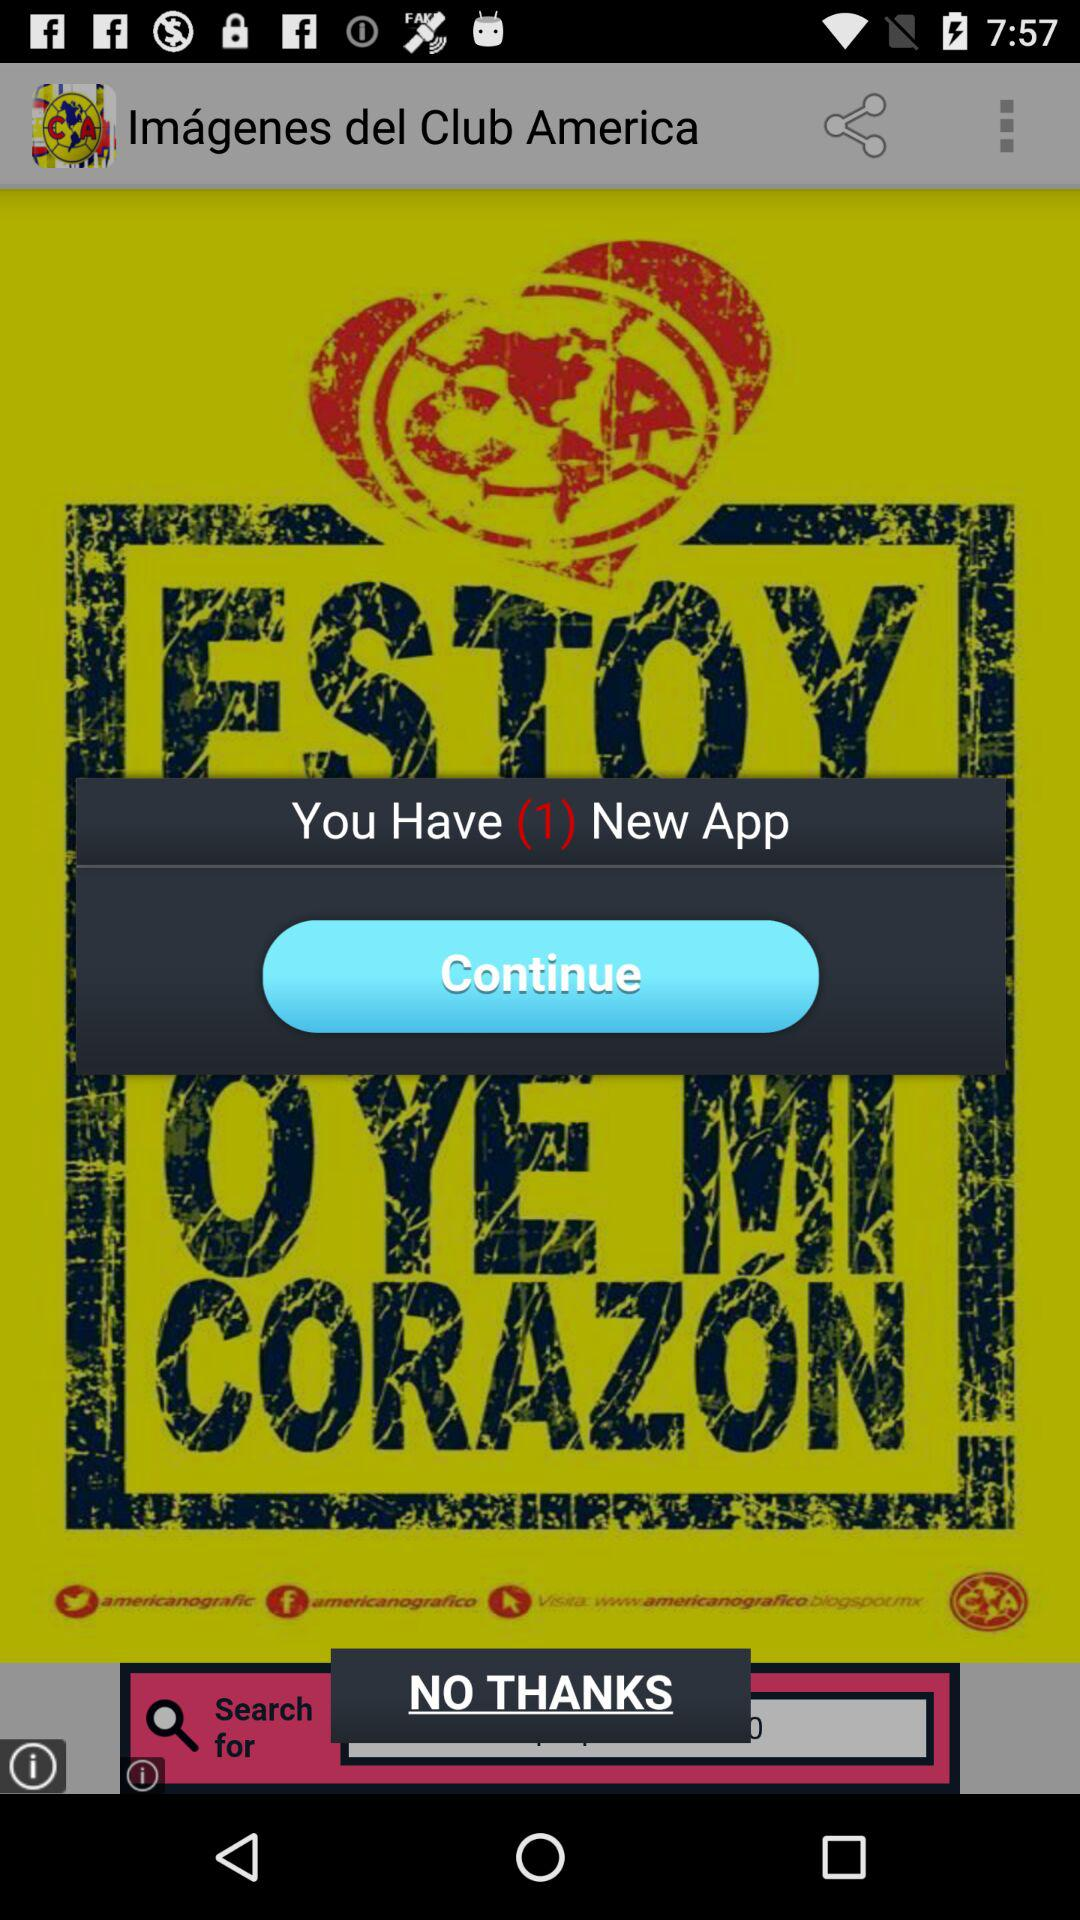How many application have to continue?
When the provided information is insufficient, respond with <no answer>. <no answer> 